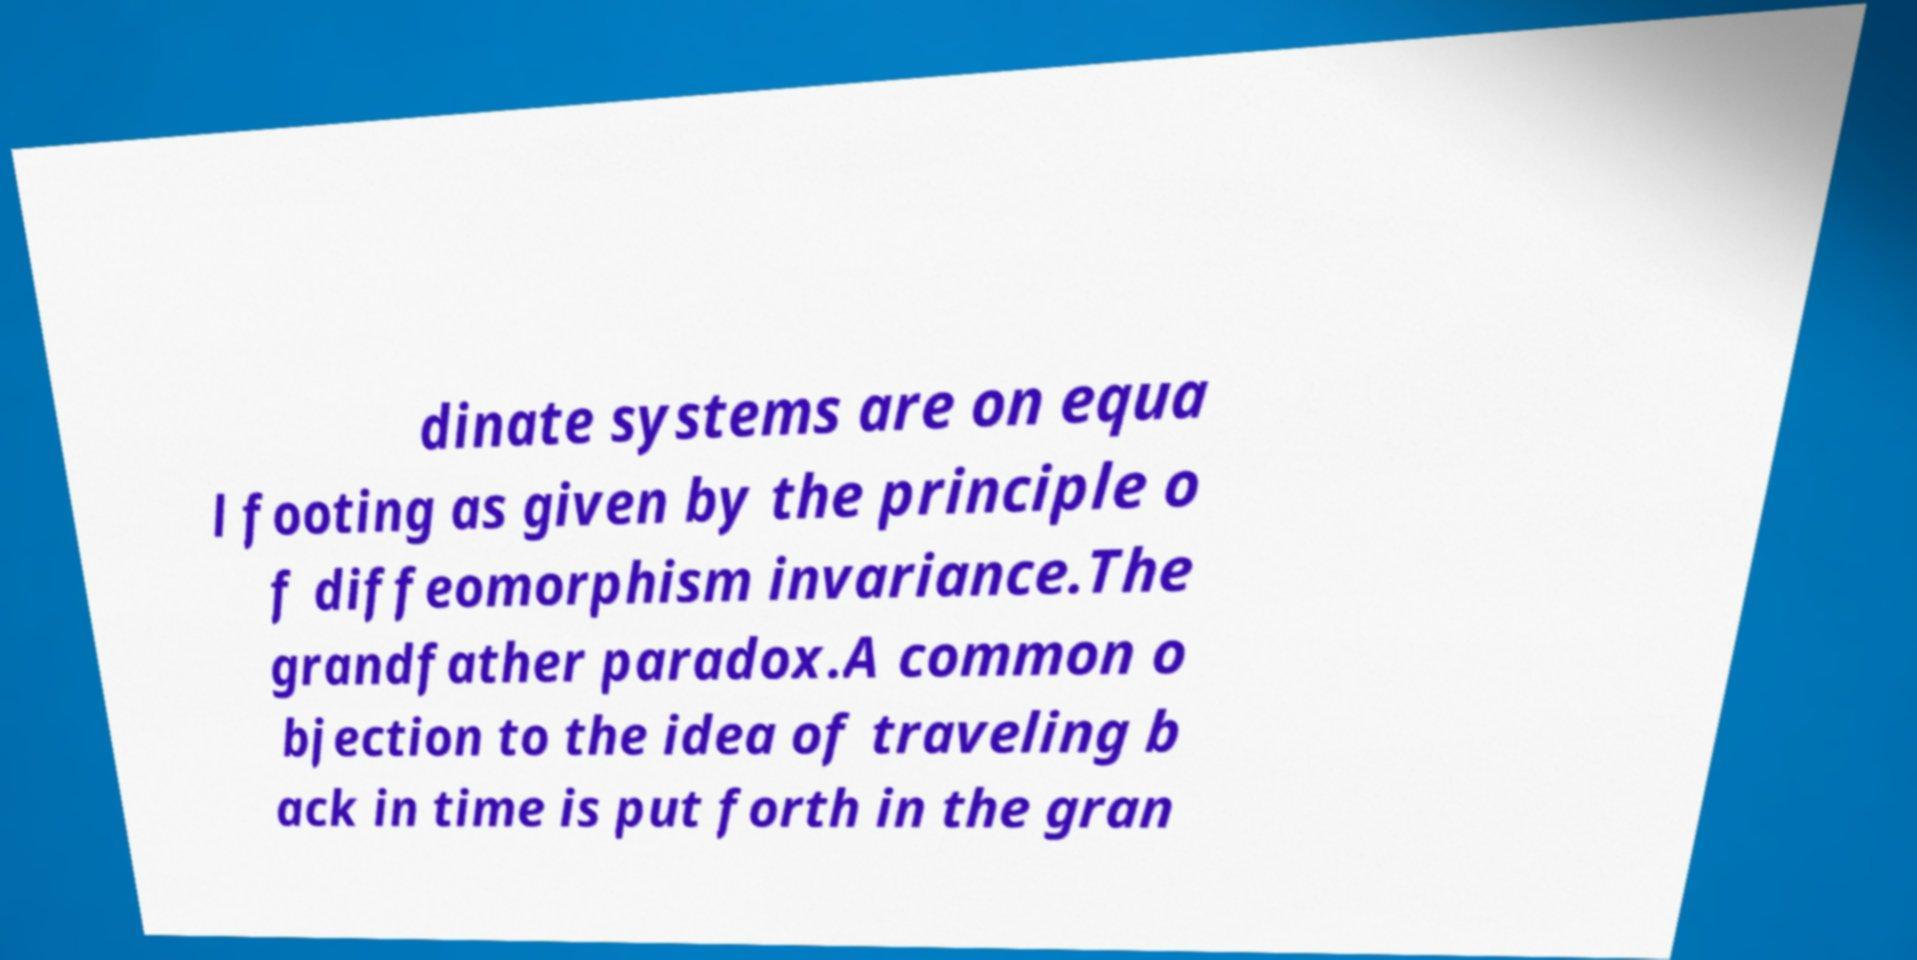Can you accurately transcribe the text from the provided image for me? dinate systems are on equa l footing as given by the principle o f diffeomorphism invariance.The grandfather paradox.A common o bjection to the idea of traveling b ack in time is put forth in the gran 